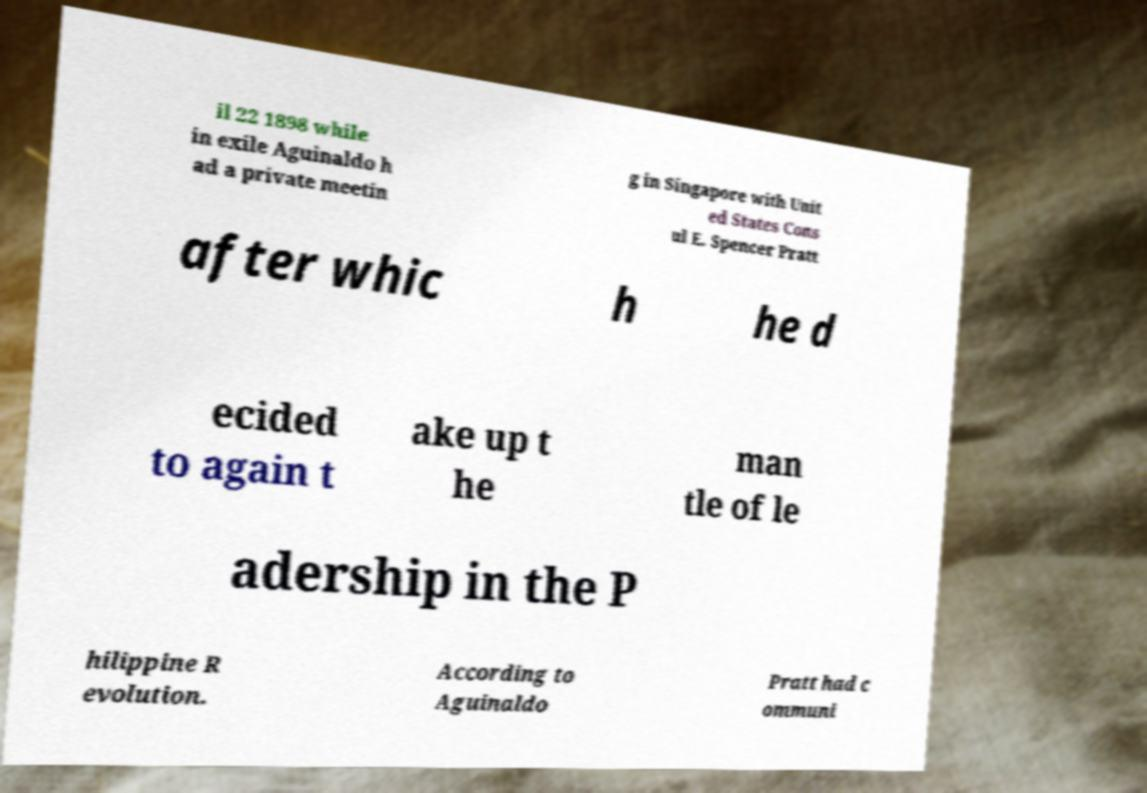I need the written content from this picture converted into text. Can you do that? il 22 1898 while in exile Aguinaldo h ad a private meetin g in Singapore with Unit ed States Cons ul E. Spencer Pratt after whic h he d ecided to again t ake up t he man tle of le adership in the P hilippine R evolution. According to Aguinaldo Pratt had c ommuni 